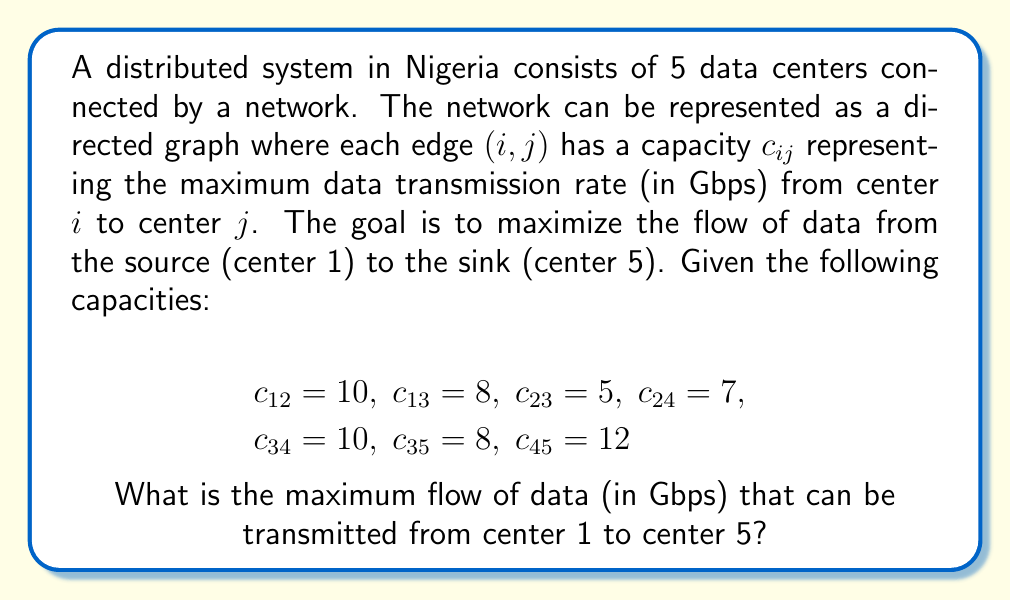Solve this math problem. To solve this problem, we'll use the Ford-Fulkerson algorithm to find the maximum flow in the network. Here's a step-by-step explanation:

1. First, let's visualize the network:

[asy]
unitsize(1cm);
pair A=(0,0), B=(2,1), C=(2,-1), D=(4,0), E=(6,0);
draw(A--B--D--E);
draw(A--C--D);
draw(B--C);
draw(C--E);
dot(A); dot(B); dot(C); dot(D); dot(E);
label("1", A, W);
label("2", B, N);
label("3", C, S);
label("4", D, N);
label("5", E, E);
label("10", (A+B)/2, N);
label("8", (A+C)/2, S);
label("5", (B+C)/2, W);
label("7", (B+D)/2, N);
label("10", (C+D)/2, S);
label("8", (C+E)/2, S);
label("12", (D+E)/2, N);
[/asy]

2. Initialize the flow on all edges to 0.

3. Find an augmenting path from source (1) to sink (5). We can use any path-finding algorithm, such as DFS or BFS. Let's find paths in this order:

   Path 1: 1 -> 2 -> 4 -> 5 (min capacity = 7)
   Path 2: 1 -> 3 -> 4 -> 5 (min capacity = 8)
   Path 3: 1 -> 3 -> 5 (min capacity = 3)

4. For each path, we augment the flow:
   
   After Path 1: Flow = 7
   After Path 2: Flow = 7 + 8 = 15
   After Path 3: Flow = 15 + 3 = 18

5. At this point, there are no more augmenting paths from source to sink. Therefore, the maximum flow has been achieved.

The Ford-Fulkerson algorithm guarantees that this is the maximum flow because it satisfies the max-flow min-cut theorem. The minimum cut in this graph (the bottleneck) is the set of edges {(1,2), (1,3), (3,5)}, which has a total capacity of 10 + 8 + 8 = 26 Gbps.

Note that our achieved flow (18 Gbps) is less than this cut capacity because some capacity is wasted due to the network structure. This is a common scenario in real-world distributed systems, where network topology can limit the achievable throughput.
Answer: The maximum flow of data that can be transmitted from center 1 to center 5 is 18 Gbps. 